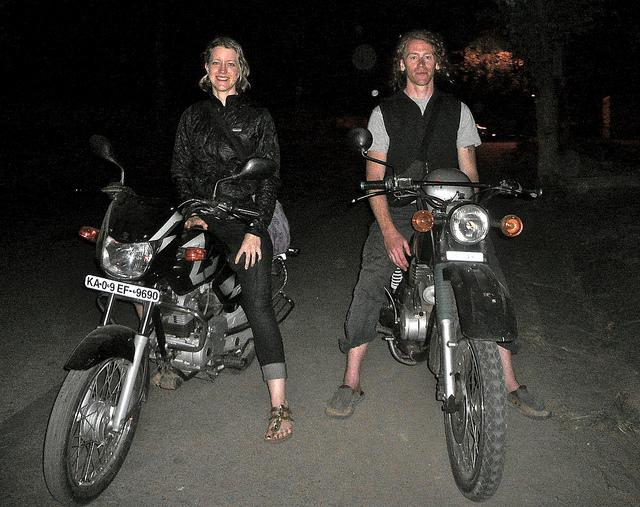Where are their helmets?
Write a very short answer. At home. What are the people riding?
Keep it brief. Motorcycles. How many people are there?
Short answer required. 2. What color is her hair?
Concise answer only. Blonde. 